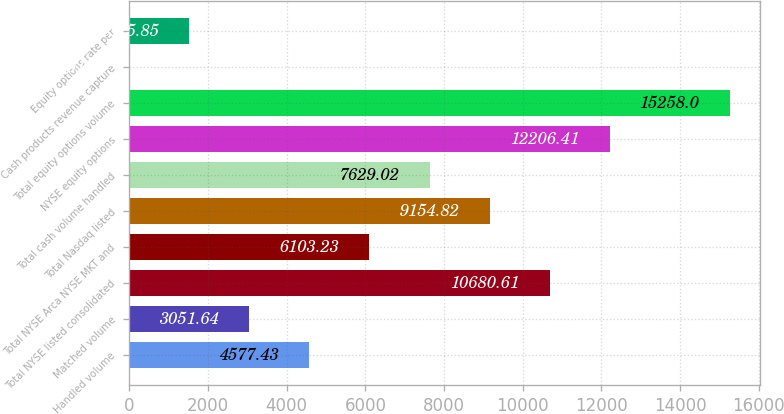<chart> <loc_0><loc_0><loc_500><loc_500><bar_chart><fcel>Handled volume<fcel>Matched volume<fcel>Total NYSE listed consolidated<fcel>Total NYSE Arca NYSE MKT and<fcel>Total Nasdaq listed<fcel>Total cash volume handled<fcel>NYSE equity options<fcel>Total equity options volume<fcel>Cash products revenue capture<fcel>Equity options rate per<nl><fcel>4577.43<fcel>3051.64<fcel>10680.6<fcel>6103.23<fcel>9154.82<fcel>7629.02<fcel>12206.4<fcel>15258<fcel>0.05<fcel>1525.85<nl></chart> 